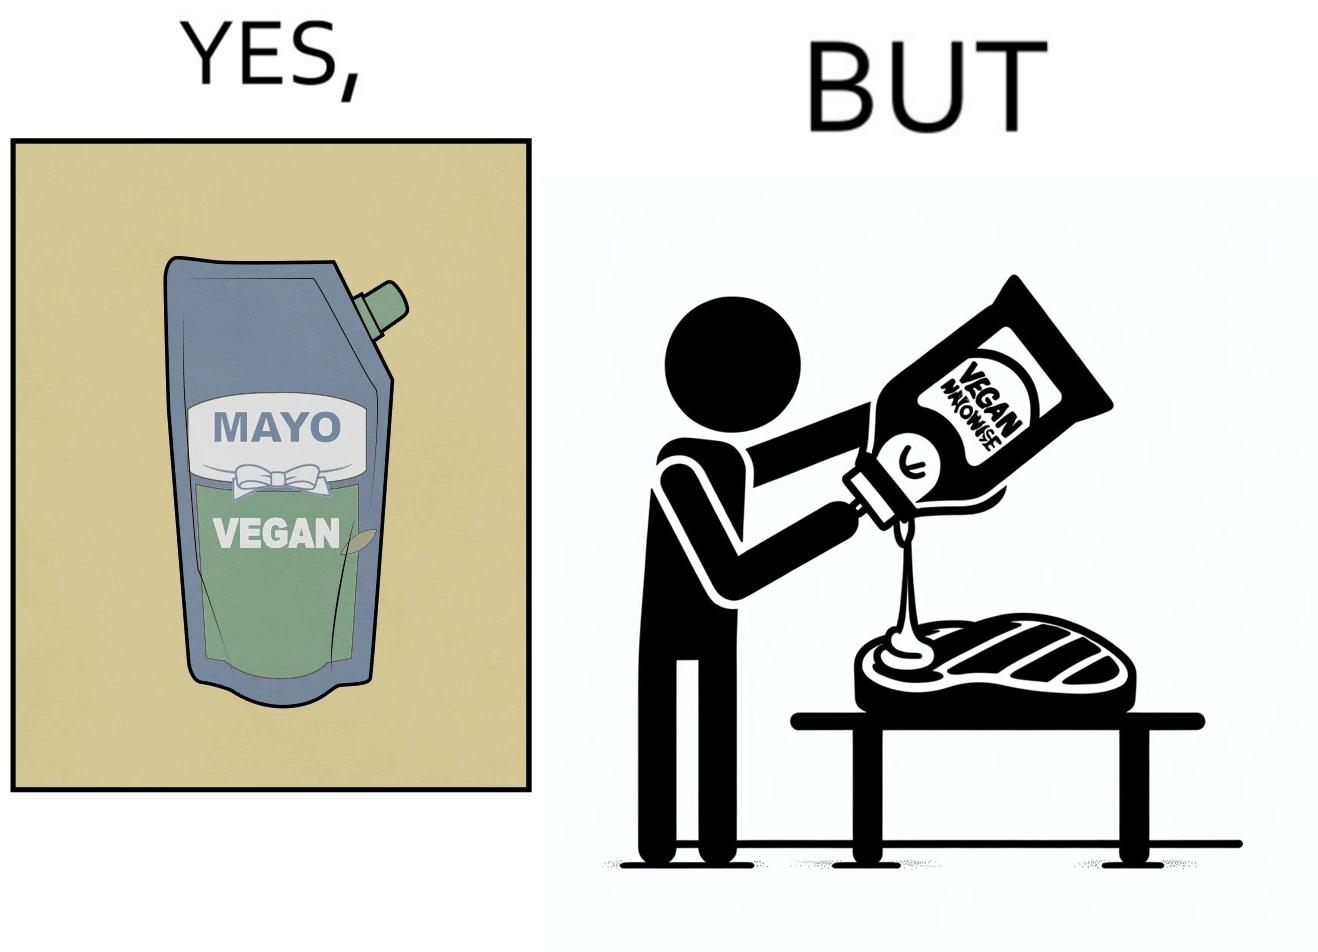What is shown in this image? The image is ironical, as vegan mayo sauce is being poured on rib steak, which is non-vegetarian. The person might as well just use normal mayo sauce instead. 